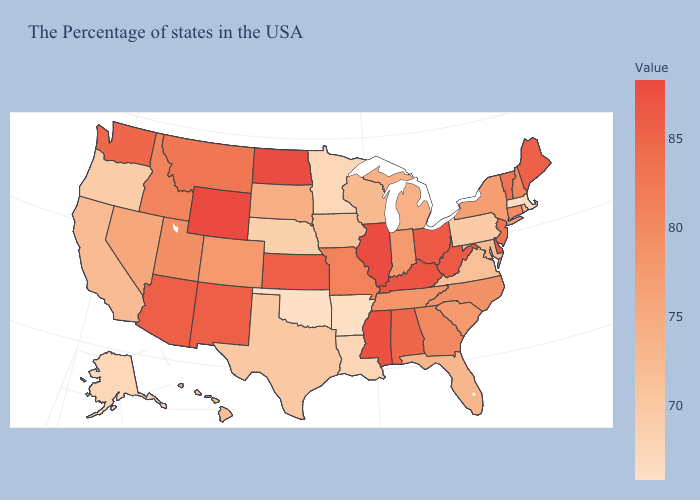Does Maryland have the highest value in the USA?
Be succinct. No. Which states hav the highest value in the West?
Answer briefly. Wyoming. Which states have the lowest value in the USA?
Keep it brief. Oklahoma. Does Ohio have the lowest value in the MidWest?
Give a very brief answer. No. Does North Carolina have the highest value in the USA?
Give a very brief answer. No. Which states hav the highest value in the South?
Concise answer only. Mississippi. Among the states that border Kentucky , which have the lowest value?
Quick response, please. Virginia. 